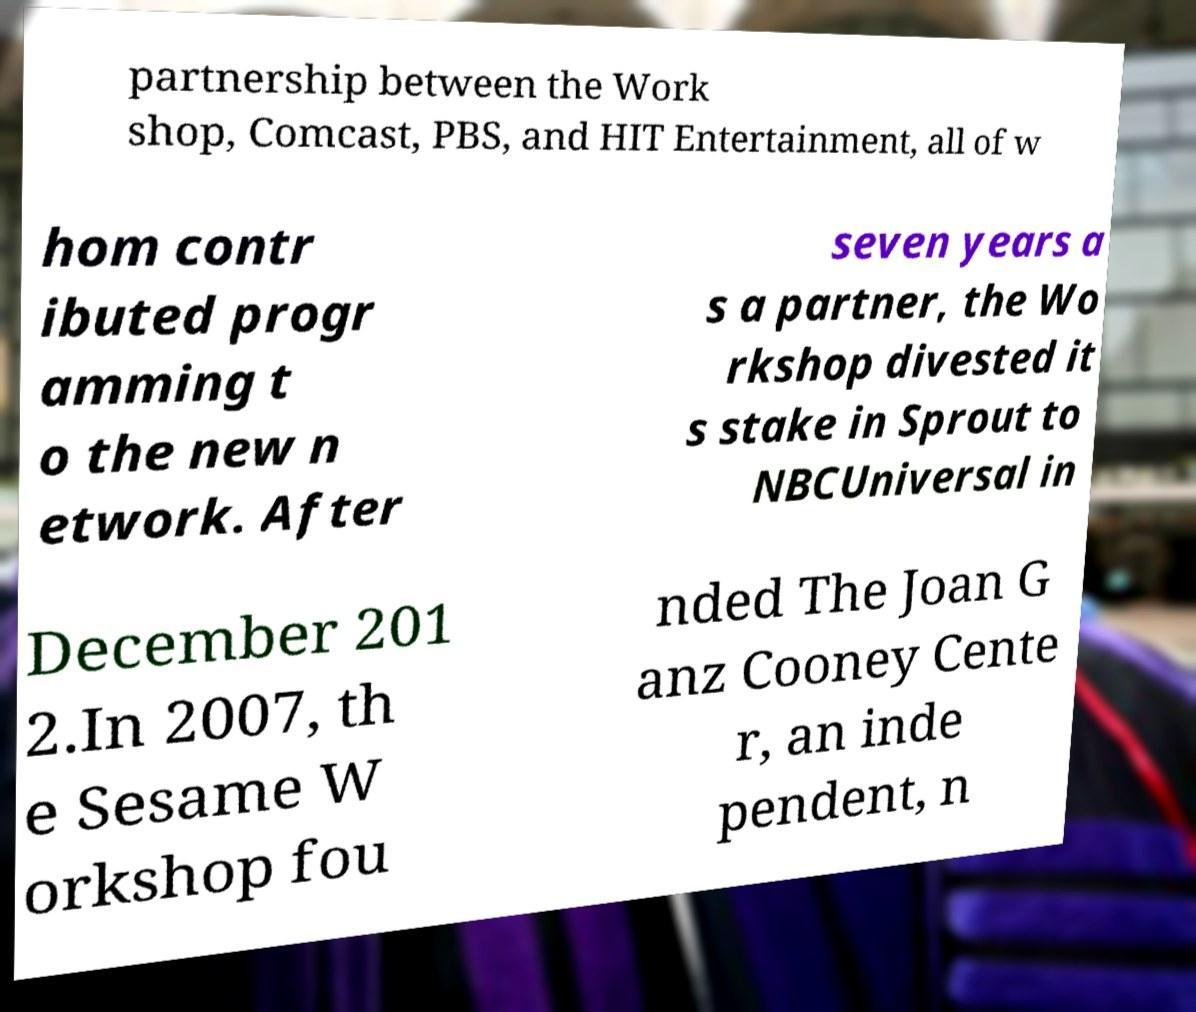Could you assist in decoding the text presented in this image and type it out clearly? partnership between the Work shop, Comcast, PBS, and HIT Entertainment, all of w hom contr ibuted progr amming t o the new n etwork. After seven years a s a partner, the Wo rkshop divested it s stake in Sprout to NBCUniversal in December 201 2.In 2007, th e Sesame W orkshop fou nded The Joan G anz Cooney Cente r, an inde pendent, n 